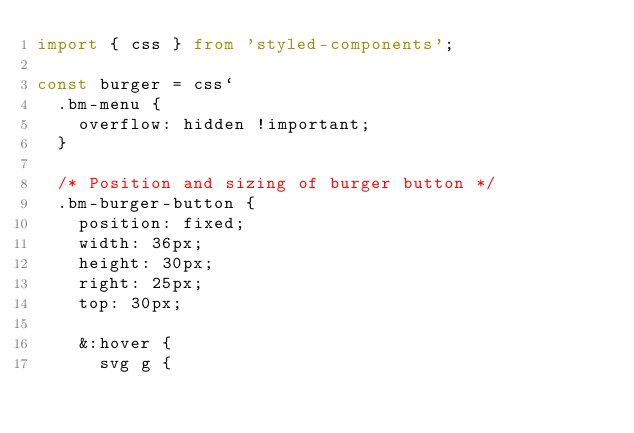<code> <loc_0><loc_0><loc_500><loc_500><_TypeScript_>import { css } from 'styled-components';

const burger = css`
  .bm-menu {
    overflow: hidden !important;
  }

  /* Position and sizing of burger button */
  .bm-burger-button {
    position: fixed;
    width: 36px;
    height: 30px;
    right: 25px;
    top: 30px;

    &:hover {
      svg g {</code> 